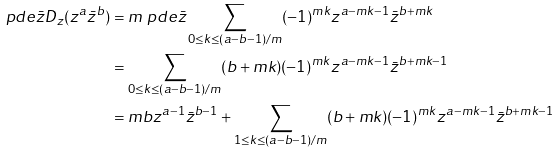<formula> <loc_0><loc_0><loc_500><loc_500>\ p d e { \bar { z } } D _ { z } ( z ^ { a } \bar { z } ^ { b } ) & = m \ p d e { \bar { z } } \sum _ { 0 \leq k \leq ( a - b - 1 ) / m } ( - 1 ) ^ { m k } z ^ { a - m k - 1 } \bar { z } ^ { b + m k } \\ & = \sum _ { 0 \leq k \leq ( a - b - 1 ) / m } ( b + m k ) ( - 1 ) ^ { m k } z ^ { a - m k - 1 } \bar { z } ^ { b + m k - 1 } \\ & = m b z ^ { a - 1 } \bar { z } ^ { b - 1 } + \sum _ { 1 \leq k \leq ( a - b - 1 ) / m } ( b + m k ) ( - 1 ) ^ { m k } z ^ { a - m k - 1 } \bar { z } ^ { b + m k - 1 }</formula> 